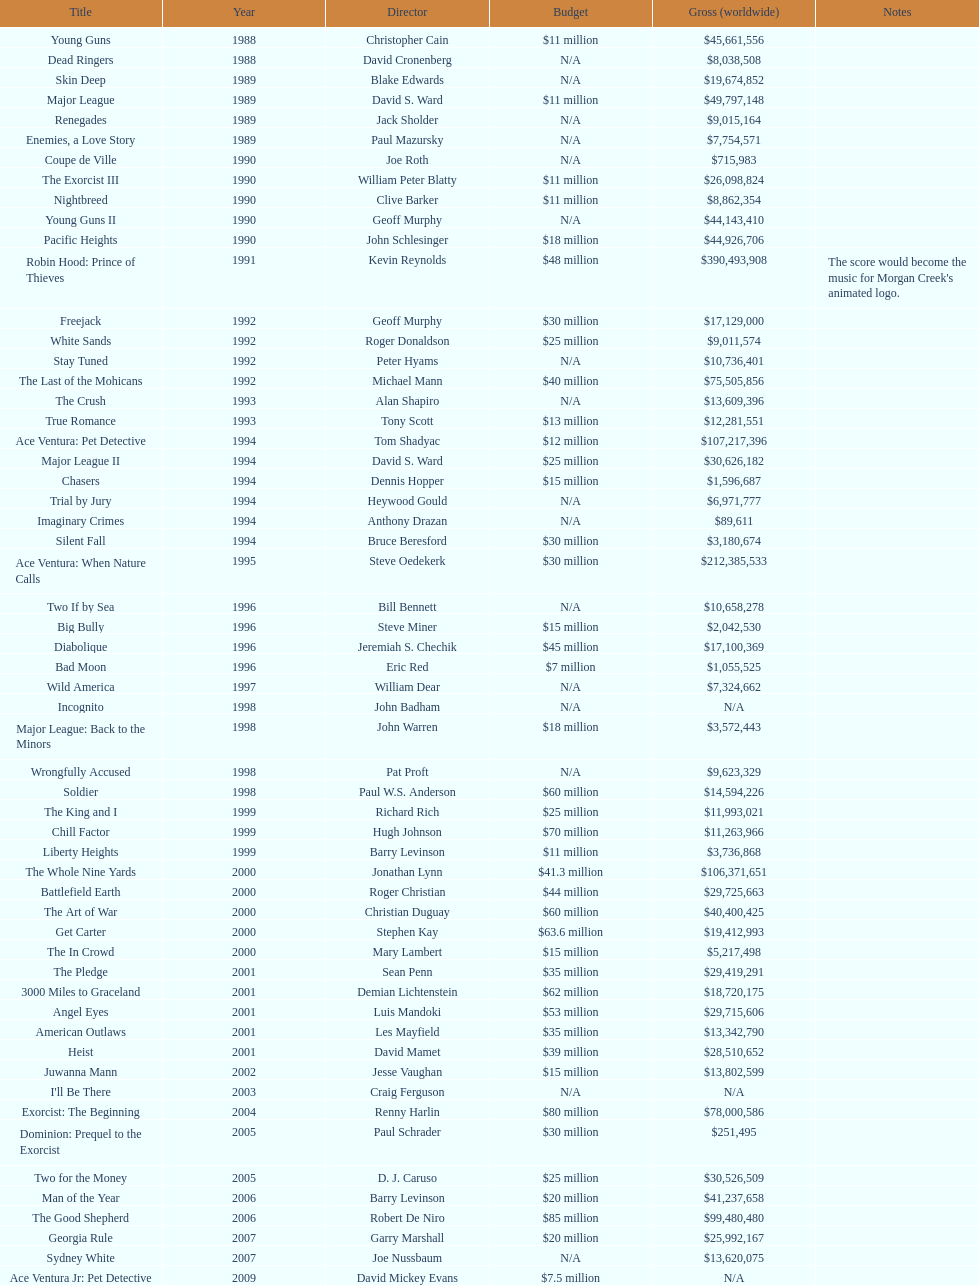What was the sole film with a 48 million dollar budget? Robin Hood: Prince of Thieves. 